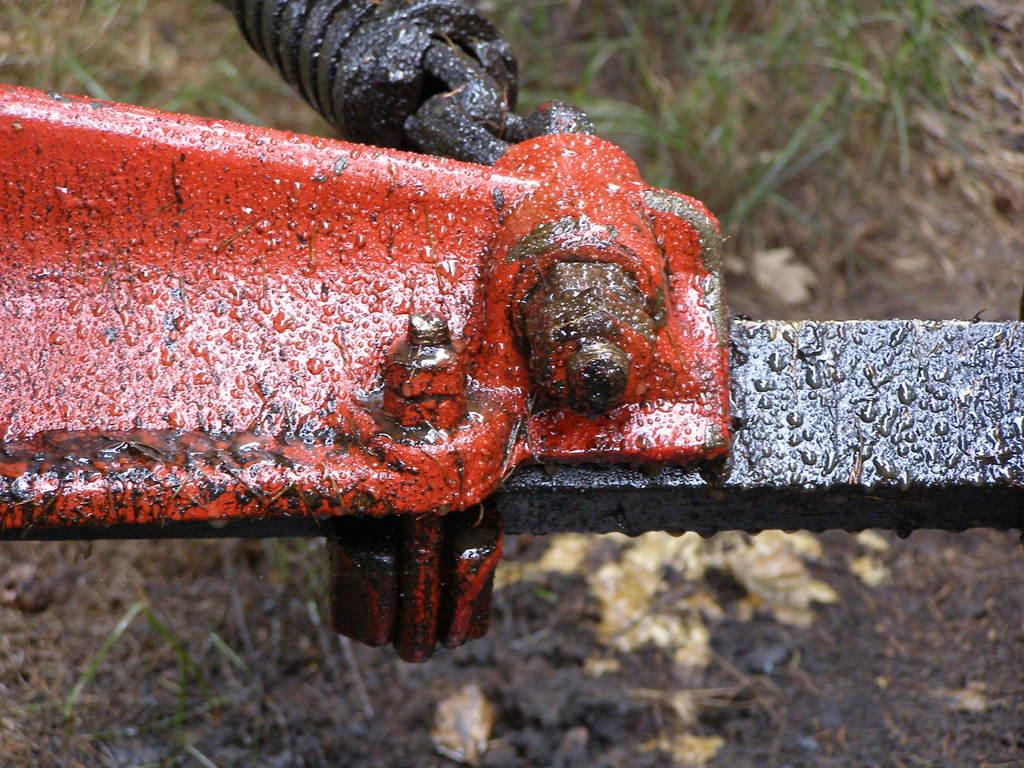What is located in the center of the image? There are iron bars in the center of the image. What type of vegetation can be seen in the background of the image? There is grass visible in the background of the image. What type of ornament is hanging from the iron bars in the image? There is no ornament hanging from the iron bars in the image; only the iron bars are present. What season is depicted in the image based on the presence of grass? The presence of grass alone does not indicate a specific season, as grass can be present in various seasons. 